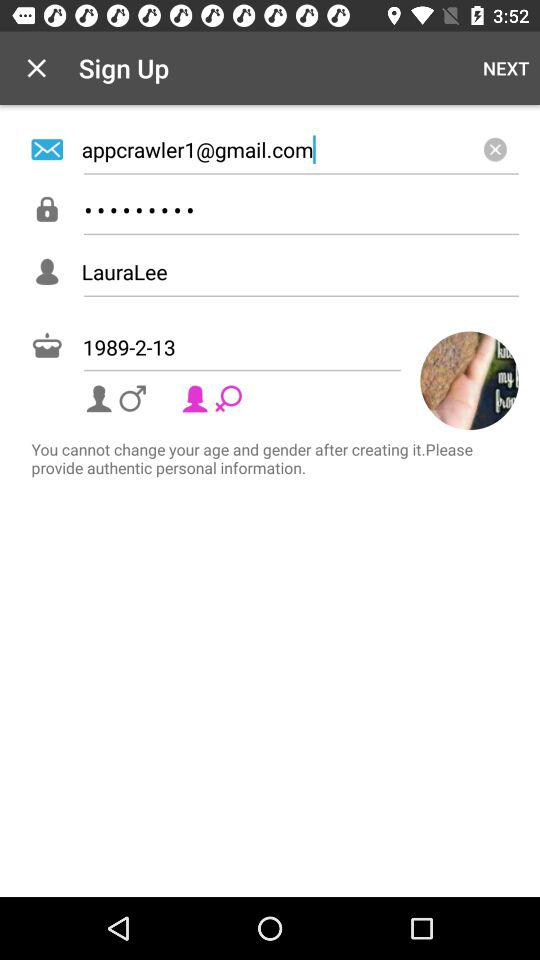What is the user name? The user name is LauraLee. 